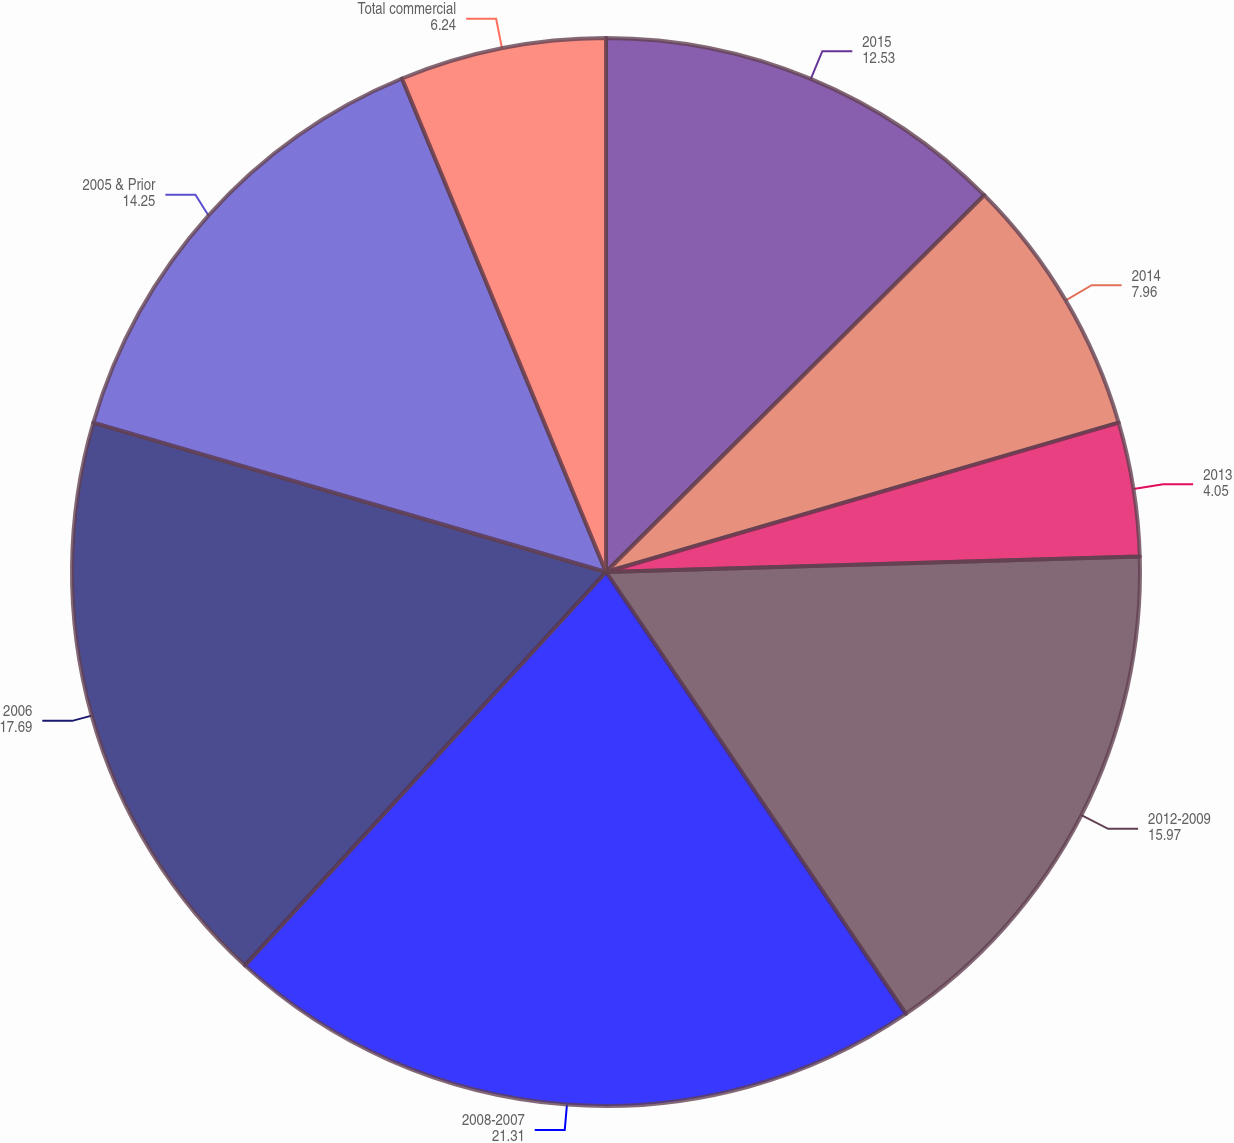<chart> <loc_0><loc_0><loc_500><loc_500><pie_chart><fcel>2015<fcel>2014<fcel>2013<fcel>2012-2009<fcel>2008-2007<fcel>2006<fcel>2005 & Prior<fcel>Total commercial<nl><fcel>12.53%<fcel>7.96%<fcel>4.05%<fcel>15.97%<fcel>21.31%<fcel>17.69%<fcel>14.25%<fcel>6.24%<nl></chart> 